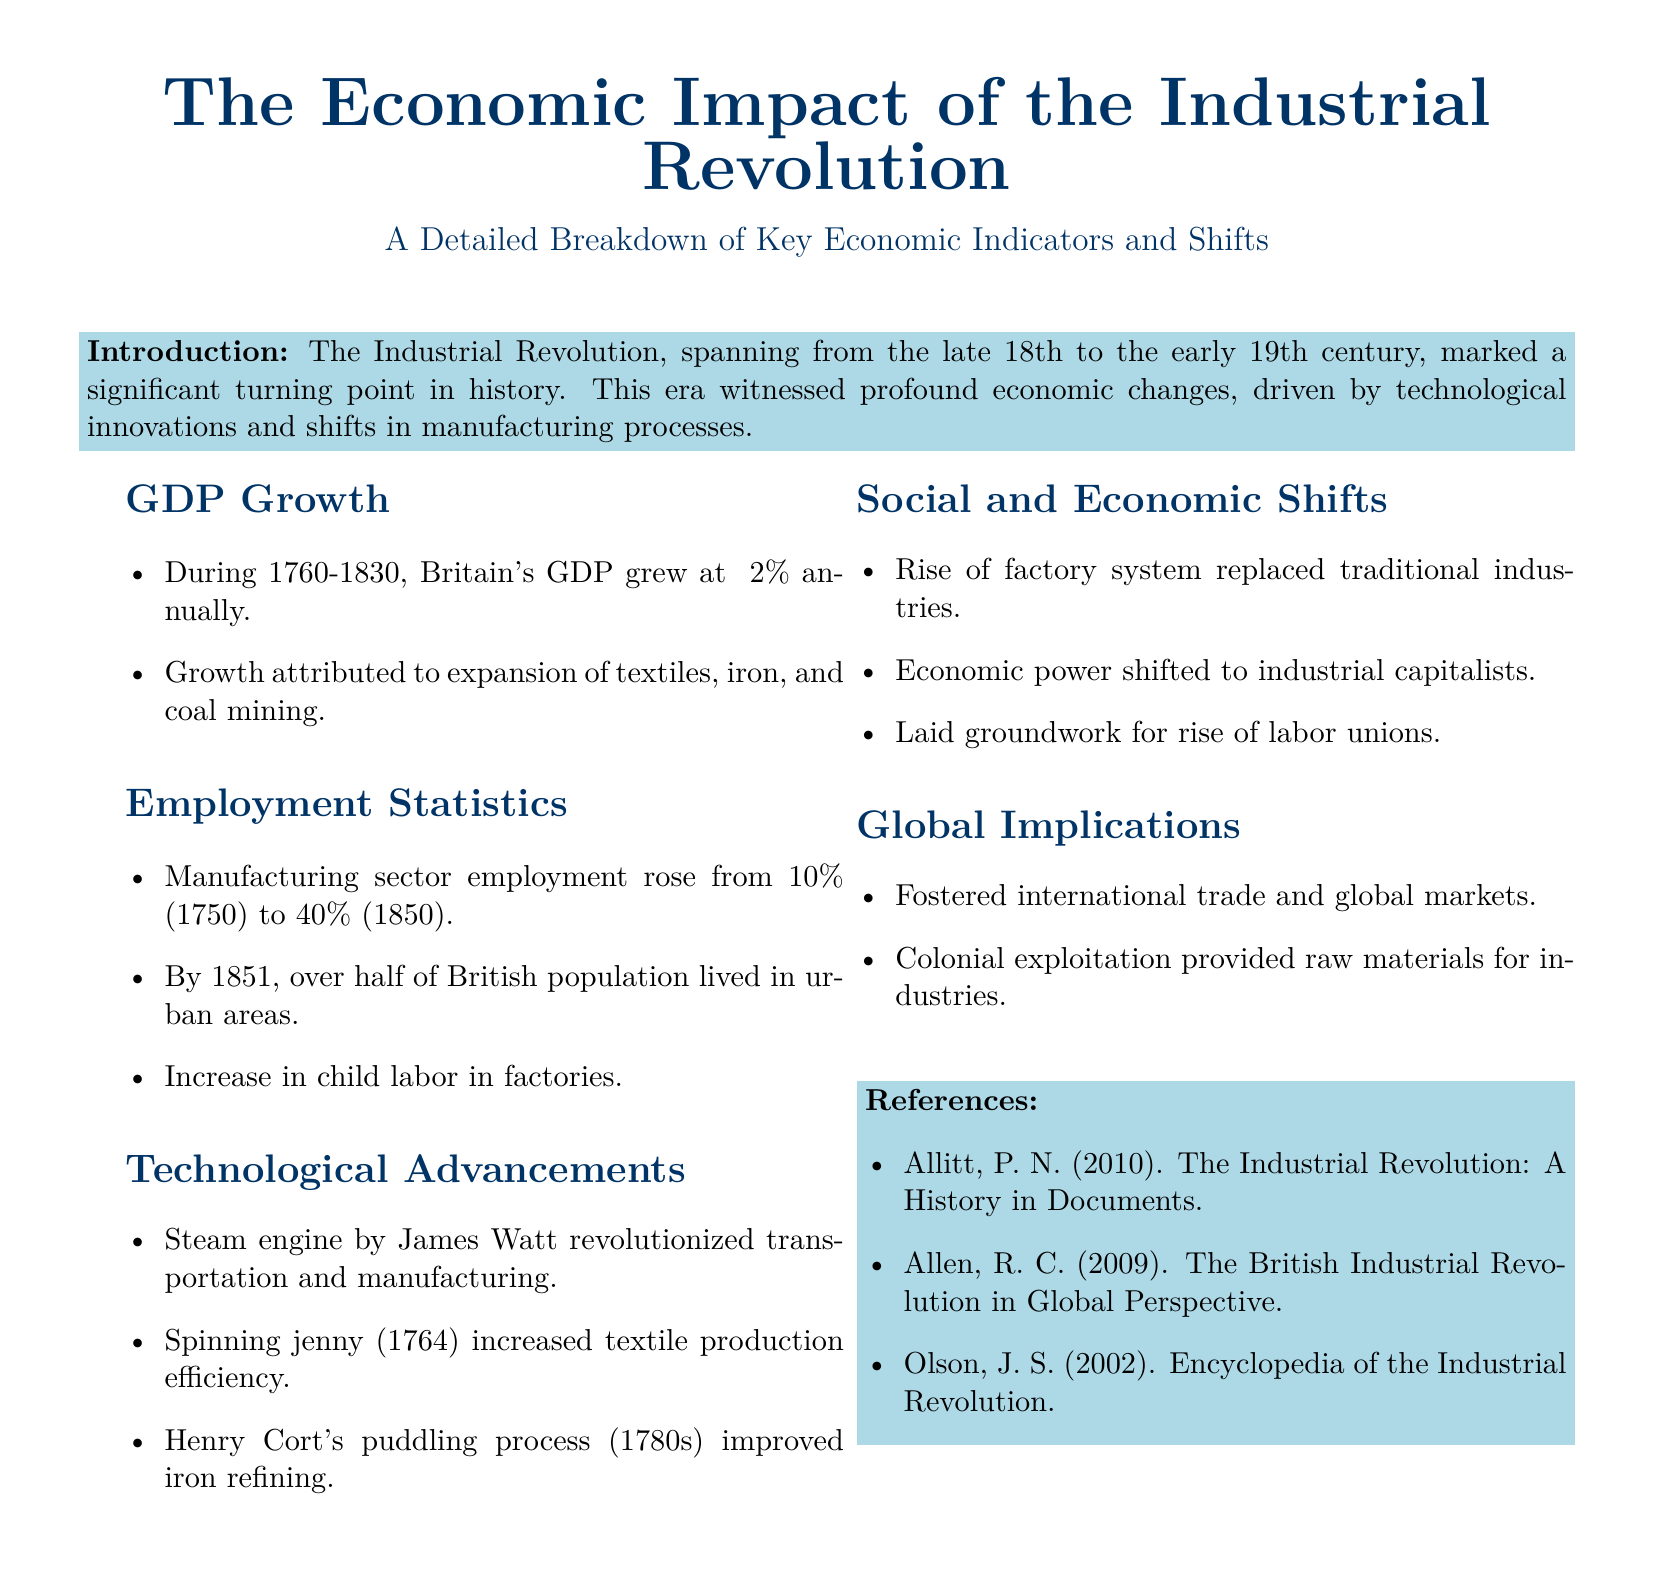What was Britain's GDP growth rate during 1760-1830? The document states that Britain's GDP grew at approximately 2% annually during this period.
Answer: 2% What percentage of the population lived in urban areas by 1851? According to the document, over half of the British population lived in urban areas by 1851.
Answer: Over half What invention by James Watt revolutionized transportation and manufacturing? The document mentions that the steam engine by James Watt revolutionized transportation and manufacturing.
Answer: Steam engine What was the manufacturing sector employment percentage in 1750? The document indicates that manufacturing sector employment was 10% in 1750.
Answer: 10% What process improved iron refining in the 1780s? According to the document, Henry Cort's puddling process improved iron refining.
Answer: Puddling process What did the rise of the factory system replace? The document states that the rise of the factory system replaced traditional industries.
Answer: Traditional industries Which historical shift fostered international trade and global markets? The document mentions that the Industrial Revolution fostered international trade and global markets.
Answer: Industrial Revolution What economic power emerged as a result of the Industrial Revolution? The document indicates that economic power shifted to industrial capitalists as a result of the Industrial Revolution.
Answer: Industrial capitalists 